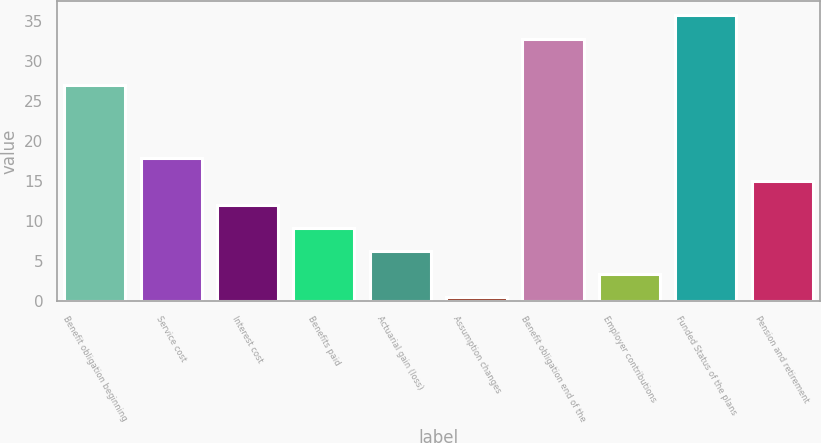<chart> <loc_0><loc_0><loc_500><loc_500><bar_chart><fcel>Benefit obligation beginning<fcel>Service cost<fcel>Interest cost<fcel>Benefits paid<fcel>Actuarial gain (loss)<fcel>Assumption changes<fcel>Benefit obligation end of the<fcel>Employer contributions<fcel>Funded Status of the plans<fcel>Pension and retirement<nl><fcel>27<fcel>17.9<fcel>12.1<fcel>9.2<fcel>6.3<fcel>0.5<fcel>32.8<fcel>3.4<fcel>35.7<fcel>15<nl></chart> 